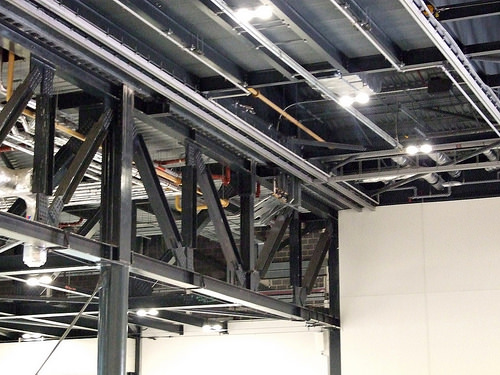<image>
Is the lights behind the trusses? Yes. From this viewpoint, the lights is positioned behind the trusses, with the trusses partially or fully occluding the lights. 